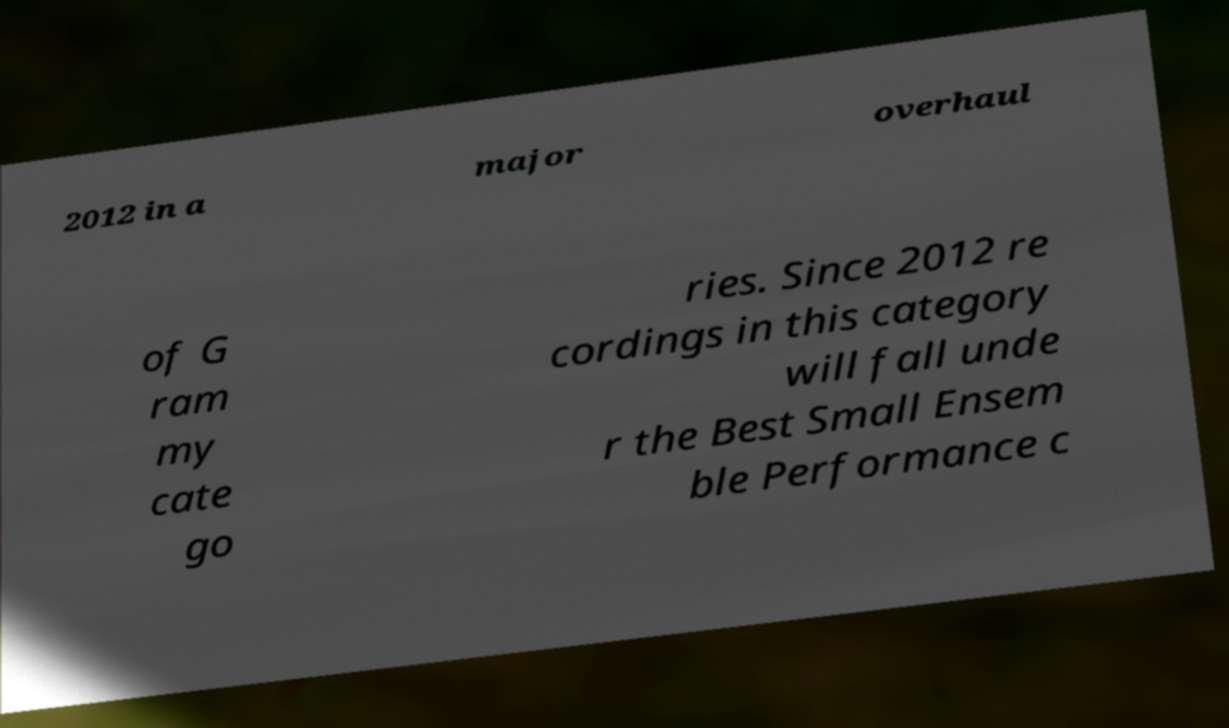Could you assist in decoding the text presented in this image and type it out clearly? 2012 in a major overhaul of G ram my cate go ries. Since 2012 re cordings in this category will fall unde r the Best Small Ensem ble Performance c 